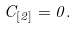Convert formula to latex. <formula><loc_0><loc_0><loc_500><loc_500>C _ { [ 2 ] } = 0 .</formula> 